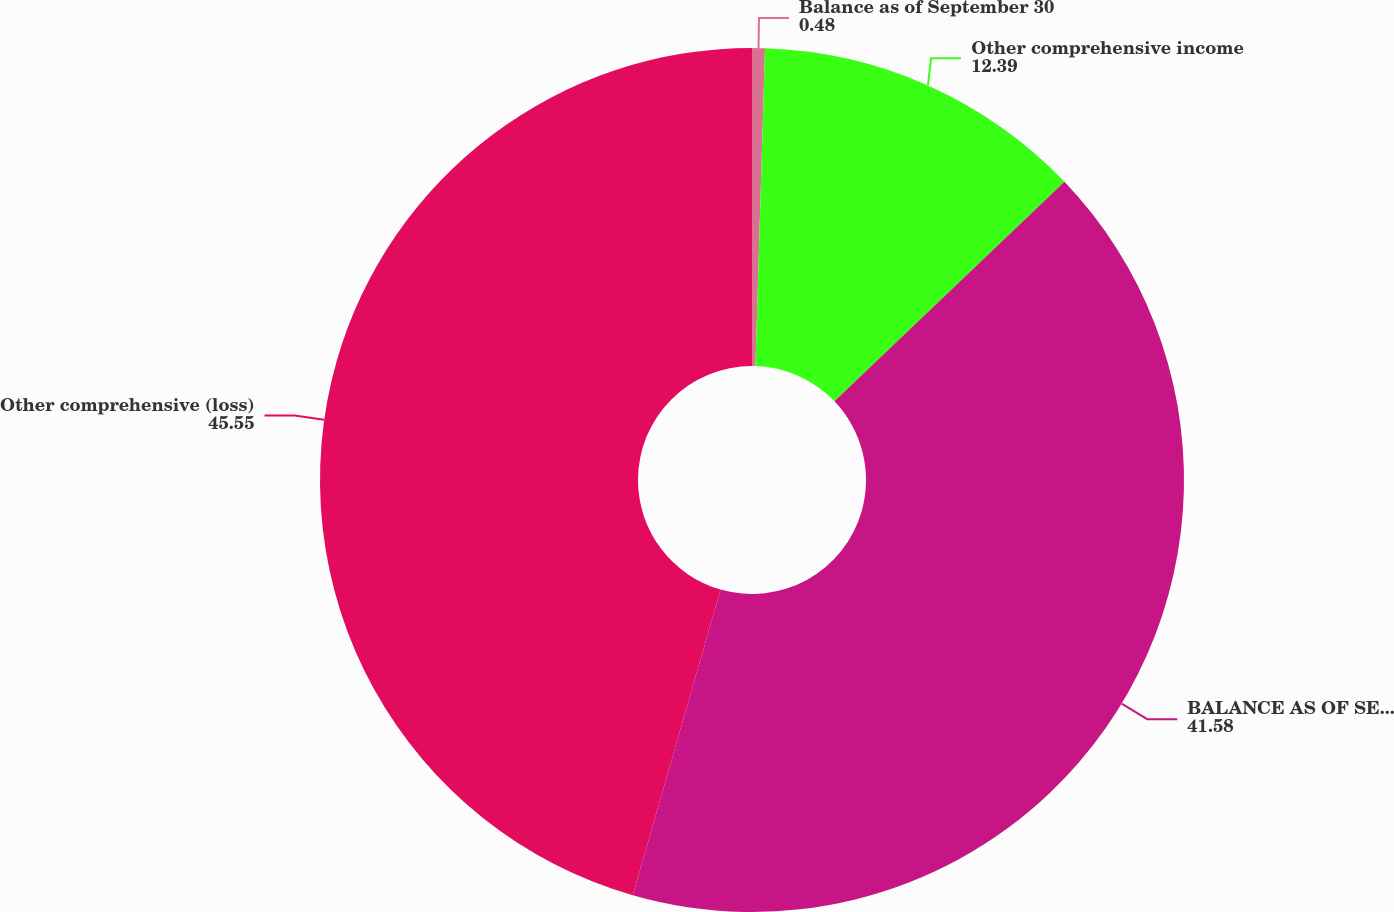<chart> <loc_0><loc_0><loc_500><loc_500><pie_chart><fcel>Balance as of September 30<fcel>Other comprehensive income<fcel>BALANCE AS OF SEPTEMBER 30<fcel>Other comprehensive (loss)<nl><fcel>0.48%<fcel>12.39%<fcel>41.58%<fcel>45.55%<nl></chart> 